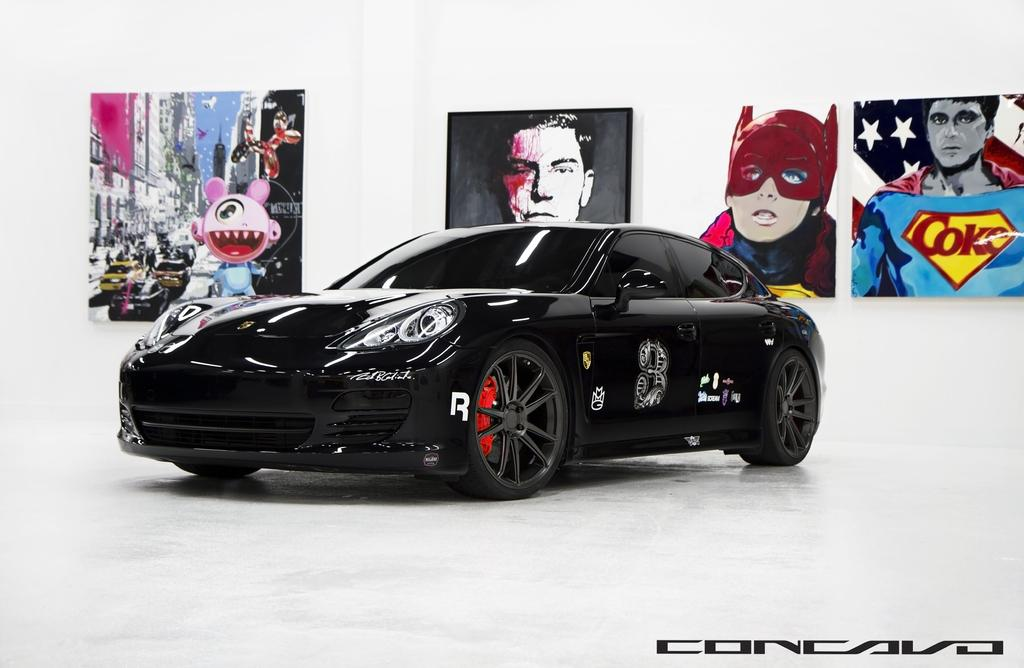What type of vehicle is in the image? There is a black Nissan sports car in the image. What can be seen in the background of the image? There are cartoon posters in the background of the image. Is there any text present in the image? Yes, there is a small quote written at the bottom of the image. How many bars of soap are visible in the image? There are no bars of soap present in the image. 